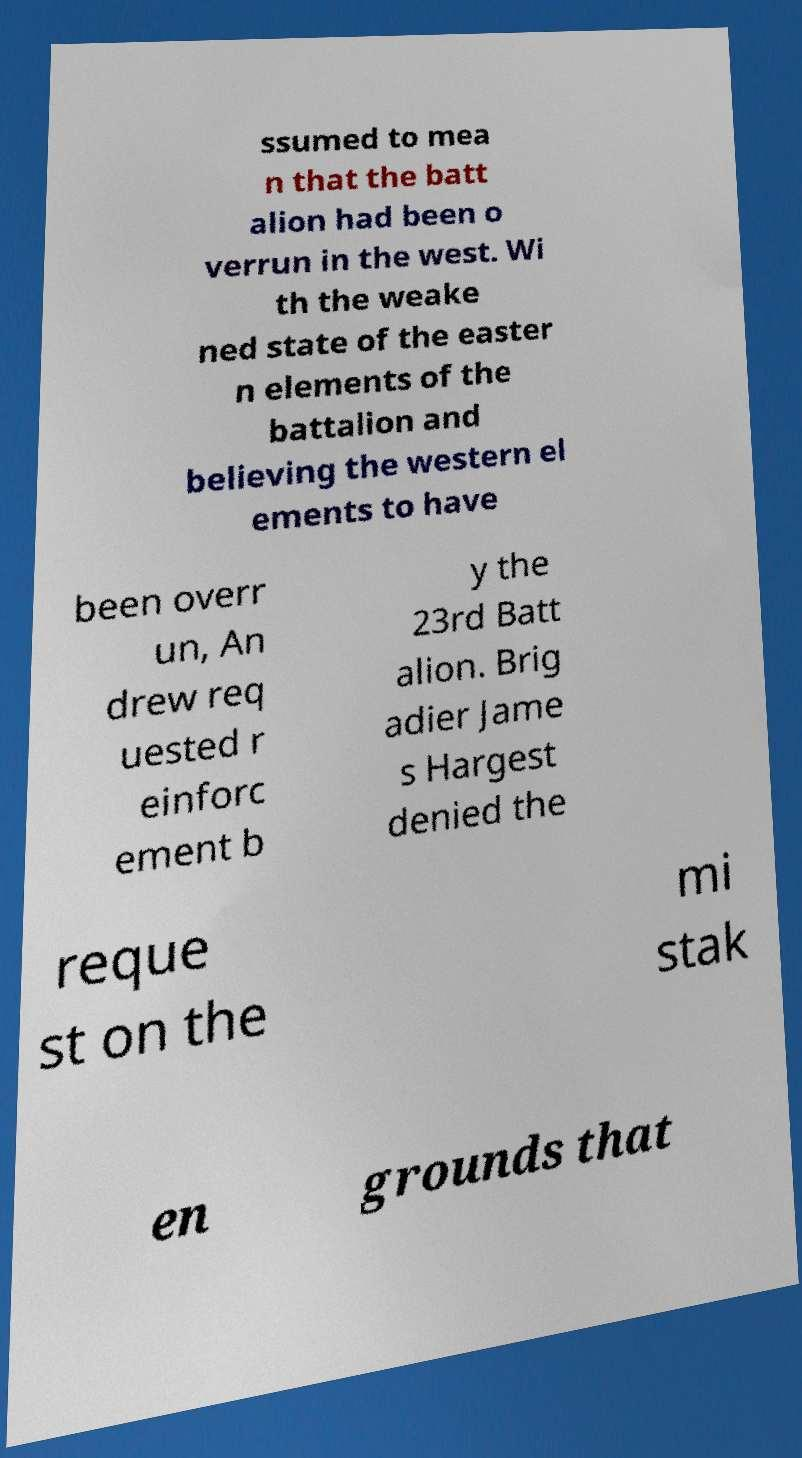I need the written content from this picture converted into text. Can you do that? ssumed to mea n that the batt alion had been o verrun in the west. Wi th the weake ned state of the easter n elements of the battalion and believing the western el ements to have been overr un, An drew req uested r einforc ement b y the 23rd Batt alion. Brig adier Jame s Hargest denied the reque st on the mi stak en grounds that 